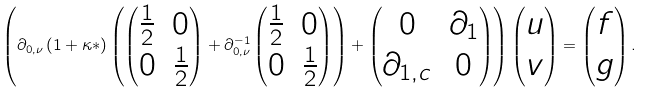Convert formula to latex. <formula><loc_0><loc_0><loc_500><loc_500>\left ( \partial _ { 0 , \nu } \left ( 1 + \kappa * \right ) \left ( \begin{pmatrix} \frac { 1 } { 2 } & 0 \\ 0 & \frac { 1 } { 2 } \end{pmatrix} + \partial _ { 0 , \nu } ^ { - 1 } \begin{pmatrix} \frac { 1 } { 2 } & 0 \\ 0 & \frac { 1 } { 2 } \end{pmatrix} \right ) + \begin{pmatrix} 0 & \partial _ { 1 } \\ \partial _ { 1 , c } & 0 \end{pmatrix} \right ) \begin{pmatrix} u \\ v \end{pmatrix} = \begin{pmatrix} f \\ g \end{pmatrix} .</formula> 